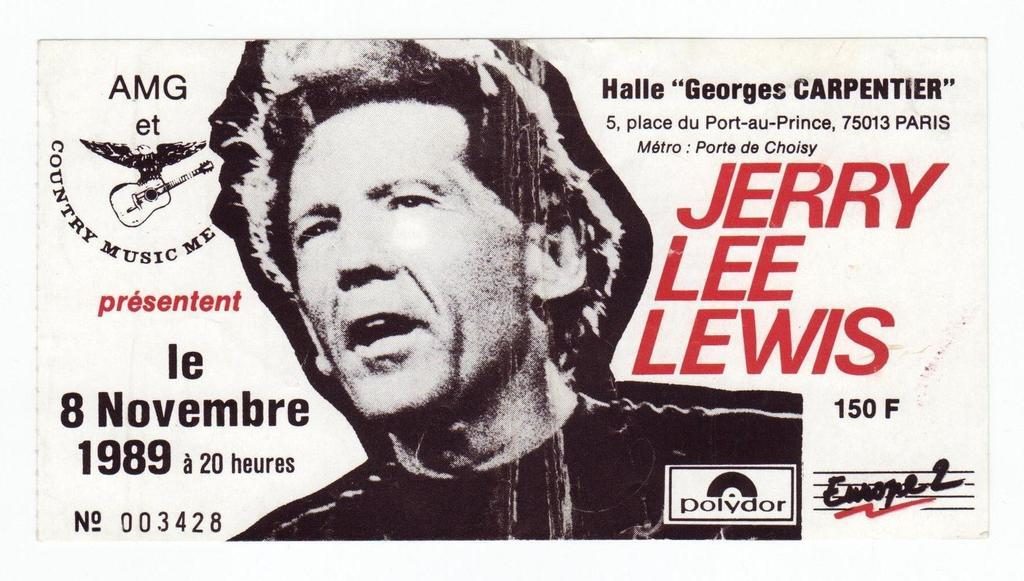What is depicted on the poster in the image? There is a poster of a man in the image. Where is the logo located in the image? The logo is on the left side of the image. How many women are depicted in the image? There are no women depicted in the image; it features a poster of a man and a logo. What emotion is the man in the poster displaying? The image does not provide information about the man's emotions, so it cannot be determined from the image. 